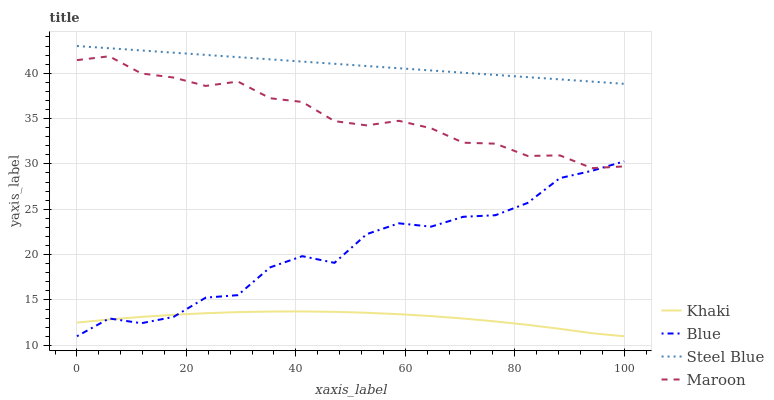Does Khaki have the minimum area under the curve?
Answer yes or no. Yes. Does Steel Blue have the maximum area under the curve?
Answer yes or no. Yes. Does Steel Blue have the minimum area under the curve?
Answer yes or no. No. Does Khaki have the maximum area under the curve?
Answer yes or no. No. Is Steel Blue the smoothest?
Answer yes or no. Yes. Is Blue the roughest?
Answer yes or no. Yes. Is Khaki the smoothest?
Answer yes or no. No. Is Khaki the roughest?
Answer yes or no. No. Does Steel Blue have the lowest value?
Answer yes or no. No. Does Steel Blue have the highest value?
Answer yes or no. Yes. Does Khaki have the highest value?
Answer yes or no. No. Is Khaki less than Steel Blue?
Answer yes or no. Yes. Is Maroon greater than Khaki?
Answer yes or no. Yes. Does Maroon intersect Blue?
Answer yes or no. Yes. Is Maroon less than Blue?
Answer yes or no. No. Is Maroon greater than Blue?
Answer yes or no. No. Does Khaki intersect Steel Blue?
Answer yes or no. No. 